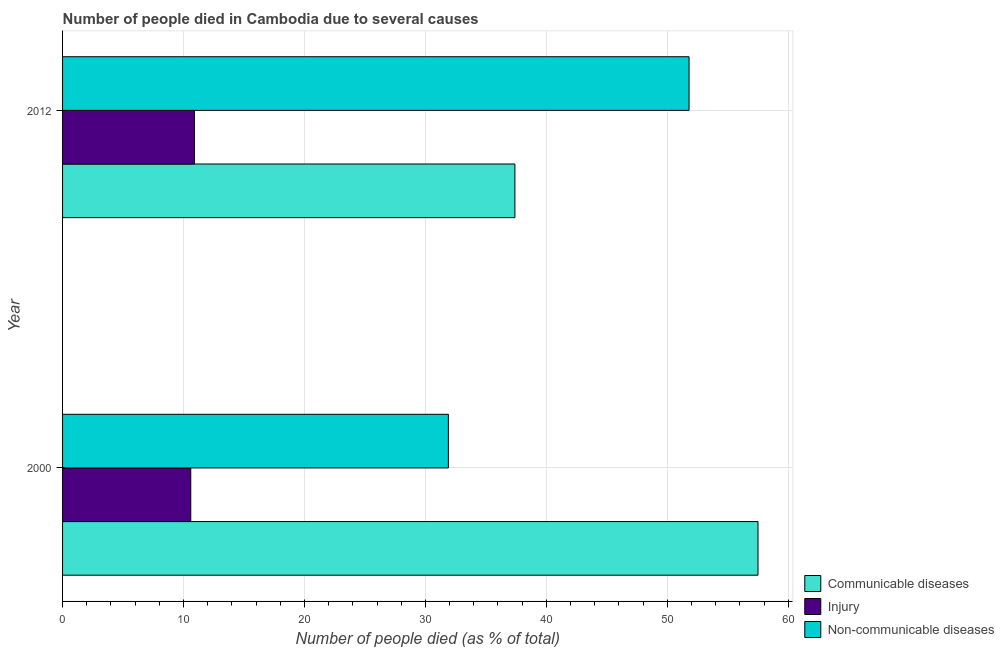How many different coloured bars are there?
Your answer should be very brief. 3. Are the number of bars per tick equal to the number of legend labels?
Keep it short and to the point. Yes. How many bars are there on the 2nd tick from the top?
Your answer should be compact. 3. In how many cases, is the number of bars for a given year not equal to the number of legend labels?
Give a very brief answer. 0. What is the number of people who dies of non-communicable diseases in 2000?
Your response must be concise. 31.9. Across all years, what is the maximum number of people who died of communicable diseases?
Your answer should be very brief. 57.5. Across all years, what is the minimum number of people who dies of non-communicable diseases?
Provide a succinct answer. 31.9. What is the total number of people who died of communicable diseases in the graph?
Offer a terse response. 94.9. What is the difference between the number of people who dies of non-communicable diseases in 2000 and that in 2012?
Keep it short and to the point. -19.9. What is the difference between the number of people who died of communicable diseases in 2000 and the number of people who dies of non-communicable diseases in 2012?
Your response must be concise. 5.7. What is the average number of people who dies of non-communicable diseases per year?
Ensure brevity in your answer.  41.85. In the year 2000, what is the difference between the number of people who died of injury and number of people who dies of non-communicable diseases?
Ensure brevity in your answer.  -21.3. In how many years, is the number of people who dies of non-communicable diseases greater than 52 %?
Ensure brevity in your answer.  0. What is the ratio of the number of people who died of communicable diseases in 2000 to that in 2012?
Your response must be concise. 1.54. Is the number of people who died of communicable diseases in 2000 less than that in 2012?
Provide a short and direct response. No. Is the difference between the number of people who died of injury in 2000 and 2012 greater than the difference between the number of people who dies of non-communicable diseases in 2000 and 2012?
Your answer should be compact. Yes. What does the 3rd bar from the top in 2012 represents?
Offer a very short reply. Communicable diseases. What does the 3rd bar from the bottom in 2000 represents?
Offer a terse response. Non-communicable diseases. Are all the bars in the graph horizontal?
Your answer should be compact. Yes. What is the difference between two consecutive major ticks on the X-axis?
Provide a succinct answer. 10. How many legend labels are there?
Offer a terse response. 3. How are the legend labels stacked?
Provide a succinct answer. Vertical. What is the title of the graph?
Ensure brevity in your answer.  Number of people died in Cambodia due to several causes. What is the label or title of the X-axis?
Give a very brief answer. Number of people died (as % of total). What is the Number of people died (as % of total) of Communicable diseases in 2000?
Your answer should be very brief. 57.5. What is the Number of people died (as % of total) of Non-communicable diseases in 2000?
Your answer should be compact. 31.9. What is the Number of people died (as % of total) in Communicable diseases in 2012?
Your answer should be compact. 37.4. What is the Number of people died (as % of total) of Injury in 2012?
Offer a very short reply. 10.9. What is the Number of people died (as % of total) in Non-communicable diseases in 2012?
Give a very brief answer. 51.8. Across all years, what is the maximum Number of people died (as % of total) in Communicable diseases?
Your answer should be very brief. 57.5. Across all years, what is the maximum Number of people died (as % of total) in Non-communicable diseases?
Make the answer very short. 51.8. Across all years, what is the minimum Number of people died (as % of total) of Communicable diseases?
Your answer should be very brief. 37.4. Across all years, what is the minimum Number of people died (as % of total) of Non-communicable diseases?
Give a very brief answer. 31.9. What is the total Number of people died (as % of total) of Communicable diseases in the graph?
Make the answer very short. 94.9. What is the total Number of people died (as % of total) in Injury in the graph?
Your answer should be very brief. 21.5. What is the total Number of people died (as % of total) in Non-communicable diseases in the graph?
Your answer should be compact. 83.7. What is the difference between the Number of people died (as % of total) of Communicable diseases in 2000 and that in 2012?
Ensure brevity in your answer.  20.1. What is the difference between the Number of people died (as % of total) of Injury in 2000 and that in 2012?
Your response must be concise. -0.3. What is the difference between the Number of people died (as % of total) in Non-communicable diseases in 2000 and that in 2012?
Offer a terse response. -19.9. What is the difference between the Number of people died (as % of total) in Communicable diseases in 2000 and the Number of people died (as % of total) in Injury in 2012?
Provide a short and direct response. 46.6. What is the difference between the Number of people died (as % of total) in Communicable diseases in 2000 and the Number of people died (as % of total) in Non-communicable diseases in 2012?
Keep it short and to the point. 5.7. What is the difference between the Number of people died (as % of total) in Injury in 2000 and the Number of people died (as % of total) in Non-communicable diseases in 2012?
Offer a very short reply. -41.2. What is the average Number of people died (as % of total) in Communicable diseases per year?
Make the answer very short. 47.45. What is the average Number of people died (as % of total) of Injury per year?
Your answer should be compact. 10.75. What is the average Number of people died (as % of total) in Non-communicable diseases per year?
Your response must be concise. 41.85. In the year 2000, what is the difference between the Number of people died (as % of total) of Communicable diseases and Number of people died (as % of total) of Injury?
Ensure brevity in your answer.  46.9. In the year 2000, what is the difference between the Number of people died (as % of total) in Communicable diseases and Number of people died (as % of total) in Non-communicable diseases?
Provide a short and direct response. 25.6. In the year 2000, what is the difference between the Number of people died (as % of total) in Injury and Number of people died (as % of total) in Non-communicable diseases?
Your response must be concise. -21.3. In the year 2012, what is the difference between the Number of people died (as % of total) in Communicable diseases and Number of people died (as % of total) in Injury?
Offer a very short reply. 26.5. In the year 2012, what is the difference between the Number of people died (as % of total) in Communicable diseases and Number of people died (as % of total) in Non-communicable diseases?
Offer a very short reply. -14.4. In the year 2012, what is the difference between the Number of people died (as % of total) in Injury and Number of people died (as % of total) in Non-communicable diseases?
Make the answer very short. -40.9. What is the ratio of the Number of people died (as % of total) in Communicable diseases in 2000 to that in 2012?
Keep it short and to the point. 1.54. What is the ratio of the Number of people died (as % of total) in Injury in 2000 to that in 2012?
Offer a very short reply. 0.97. What is the ratio of the Number of people died (as % of total) in Non-communicable diseases in 2000 to that in 2012?
Ensure brevity in your answer.  0.62. What is the difference between the highest and the second highest Number of people died (as % of total) in Communicable diseases?
Provide a short and direct response. 20.1. What is the difference between the highest and the second highest Number of people died (as % of total) in Injury?
Your answer should be compact. 0.3. What is the difference between the highest and the lowest Number of people died (as % of total) in Communicable diseases?
Offer a very short reply. 20.1. What is the difference between the highest and the lowest Number of people died (as % of total) in Non-communicable diseases?
Ensure brevity in your answer.  19.9. 